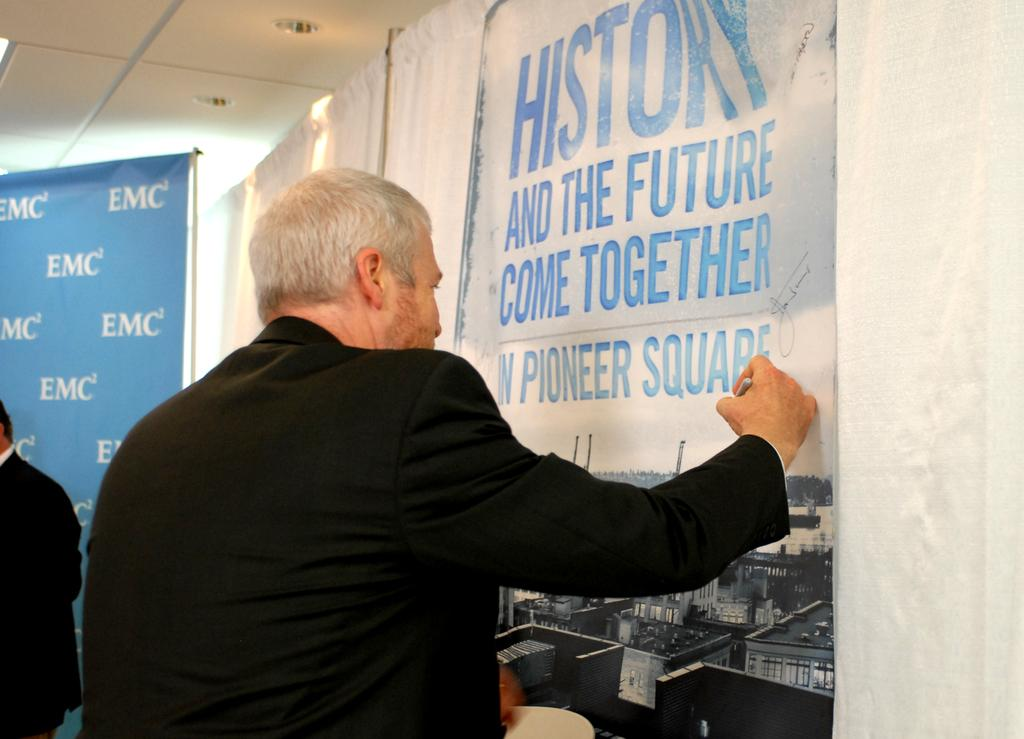Provide a one-sentence caption for the provided image. A man signs a poster advertising an event in Pioneer Square. 